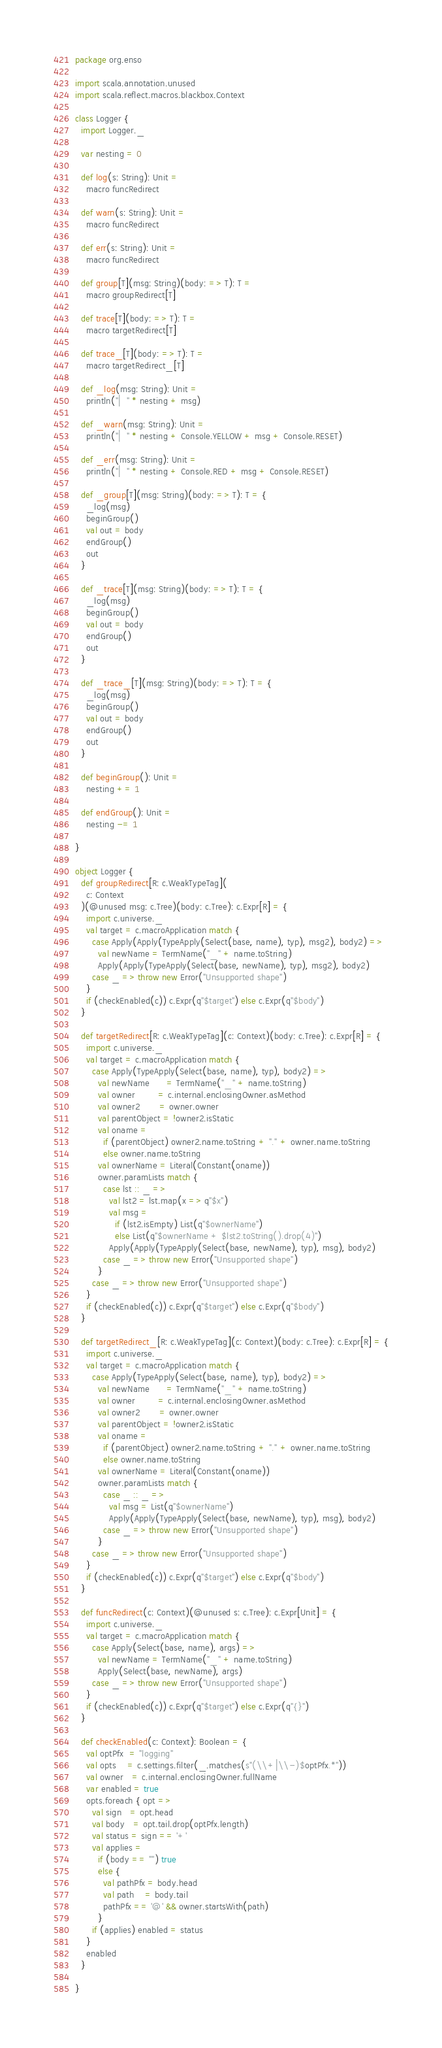<code> <loc_0><loc_0><loc_500><loc_500><_Scala_>package org.enso

import scala.annotation.unused
import scala.reflect.macros.blackbox.Context

class Logger {
  import Logger._

  var nesting = 0

  def log(s: String): Unit =
    macro funcRedirect

  def warn(s: String): Unit =
    macro funcRedirect

  def err(s: String): Unit =
    macro funcRedirect

  def group[T](msg: String)(body: => T): T =
    macro groupRedirect[T]

  def trace[T](body: => T): T =
    macro targetRedirect[T]

  def trace_[T](body: => T): T =
    macro targetRedirect_[T]

  def _log(msg: String): Unit =
    println("|  " * nesting + msg)

  def _warn(msg: String): Unit =
    println("|  " * nesting + Console.YELLOW + msg + Console.RESET)

  def _err(msg: String): Unit =
    println("|  " * nesting + Console.RED + msg + Console.RESET)

  def _group[T](msg: String)(body: => T): T = {
    _log(msg)
    beginGroup()
    val out = body
    endGroup()
    out
  }

  def _trace[T](msg: String)(body: => T): T = {
    _log(msg)
    beginGroup()
    val out = body
    endGroup()
    out
  }

  def _trace_[T](msg: String)(body: => T): T = {
    _log(msg)
    beginGroup()
    val out = body
    endGroup()
    out
  }

  def beginGroup(): Unit =
    nesting += 1

  def endGroup(): Unit =
    nesting -= 1

}

object Logger {
  def groupRedirect[R: c.WeakTypeTag](
    c: Context
  )(@unused msg: c.Tree)(body: c.Tree): c.Expr[R] = {
    import c.universe._
    val target = c.macroApplication match {
      case Apply(Apply(TypeApply(Select(base, name), typ), msg2), body2) =>
        val newName = TermName("_" + name.toString)
        Apply(Apply(TypeApply(Select(base, newName), typ), msg2), body2)
      case _ => throw new Error("Unsupported shape")
    }
    if (checkEnabled(c)) c.Expr(q"$target") else c.Expr(q"$body")
  }

  def targetRedirect[R: c.WeakTypeTag](c: Context)(body: c.Tree): c.Expr[R] = {
    import c.universe._
    val target = c.macroApplication match {
      case Apply(TypeApply(Select(base, name), typ), body2) =>
        val newName      = TermName("_" + name.toString)
        val owner        = c.internal.enclosingOwner.asMethod
        val owner2       = owner.owner
        val parentObject = !owner2.isStatic
        val oname =
          if (parentObject) owner2.name.toString + "." + owner.name.toString
          else owner.name.toString
        val ownerName = Literal(Constant(oname))
        owner.paramLists match {
          case lst :: _ =>
            val lst2 = lst.map(x => q"$x")
            val msg =
              if (lst2.isEmpty) List(q"$ownerName")
              else List(q"$ownerName + $lst2.toString().drop(4)")
            Apply(Apply(TypeApply(Select(base, newName), typ), msg), body2)
          case _ => throw new Error("Unsupported shape")
        }
      case _ => throw new Error("Unsupported shape")
    }
    if (checkEnabled(c)) c.Expr(q"$target") else c.Expr(q"$body")
  }

  def targetRedirect_[R: c.WeakTypeTag](c: Context)(body: c.Tree): c.Expr[R] = {
    import c.universe._
    val target = c.macroApplication match {
      case Apply(TypeApply(Select(base, name), typ), body2) =>
        val newName      = TermName("_" + name.toString)
        val owner        = c.internal.enclosingOwner.asMethod
        val owner2       = owner.owner
        val parentObject = !owner2.isStatic
        val oname =
          if (parentObject) owner2.name.toString + "." + owner.name.toString
          else owner.name.toString
        val ownerName = Literal(Constant(oname))
        owner.paramLists match {
          case _ :: _ =>
            val msg = List(q"$ownerName")
            Apply(Apply(TypeApply(Select(base, newName), typ), msg), body2)
          case _ => throw new Error("Unsupported shape")
        }
      case _ => throw new Error("Unsupported shape")
    }
    if (checkEnabled(c)) c.Expr(q"$target") else c.Expr(q"$body")
  }

  def funcRedirect(c: Context)(@unused s: c.Tree): c.Expr[Unit] = {
    import c.universe._
    val target = c.macroApplication match {
      case Apply(Select(base, name), args) =>
        val newName = TermName("_" + name.toString)
        Apply(Select(base, newName), args)
      case _ => throw new Error("Unsupported shape")
    }
    if (checkEnabled(c)) c.Expr(q"$target") else c.Expr(q"{}")
  }

  def checkEnabled(c: Context): Boolean = {
    val optPfx  = "logging"
    val opts    = c.settings.filter(_.matches(s"(\\+|\\-)$optPfx.*"))
    val owner   = c.internal.enclosingOwner.fullName
    var enabled = true
    opts.foreach { opt =>
      val sign   = opt.head
      val body   = opt.tail.drop(optPfx.length)
      val status = sign == '+'
      val applies =
        if (body == "") true
        else {
          val pathPfx = body.head
          val path    = body.tail
          pathPfx == '@' && owner.startsWith(path)
        }
      if (applies) enabled = status
    }
    enabled
  }

}
</code> 